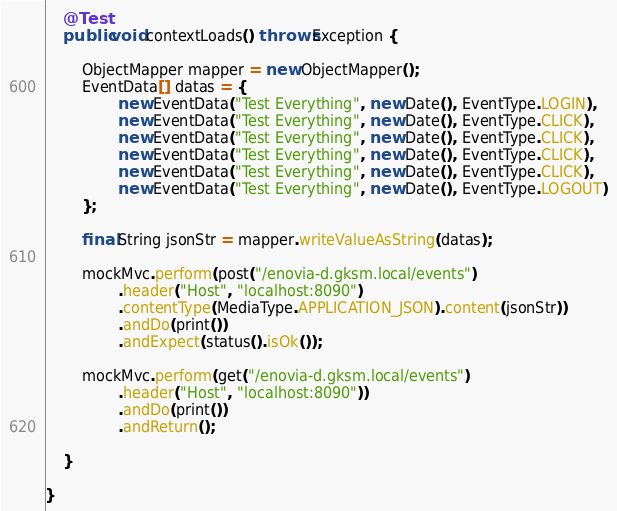<code> <loc_0><loc_0><loc_500><loc_500><_Java_>    @Test
    public void contextLoads() throws Exception {

        ObjectMapper mapper = new ObjectMapper();
        EventData[] datas = {
                new EventData("Test Everything", new Date(), EventType.LOGIN),
                new EventData("Test Everything", new Date(), EventType.CLICK),
                new EventData("Test Everything", new Date(), EventType.CLICK),
                new EventData("Test Everything", new Date(), EventType.CLICK),
                new EventData("Test Everything", new Date(), EventType.CLICK),
                new EventData("Test Everything", new Date(), EventType.LOGOUT)
        };

        final String jsonStr = mapper.writeValueAsString(datas);

        mockMvc.perform(post("/enovia-d.gksm.local/events")
                .header("Host", "localhost:8090")
                .contentType(MediaType.APPLICATION_JSON).content(jsonStr))
                .andDo(print())
                .andExpect(status().isOk());

        mockMvc.perform(get("/enovia-d.gksm.local/events")
                .header("Host", "localhost:8090"))
                .andDo(print())
                .andReturn();

    }

}
</code> 